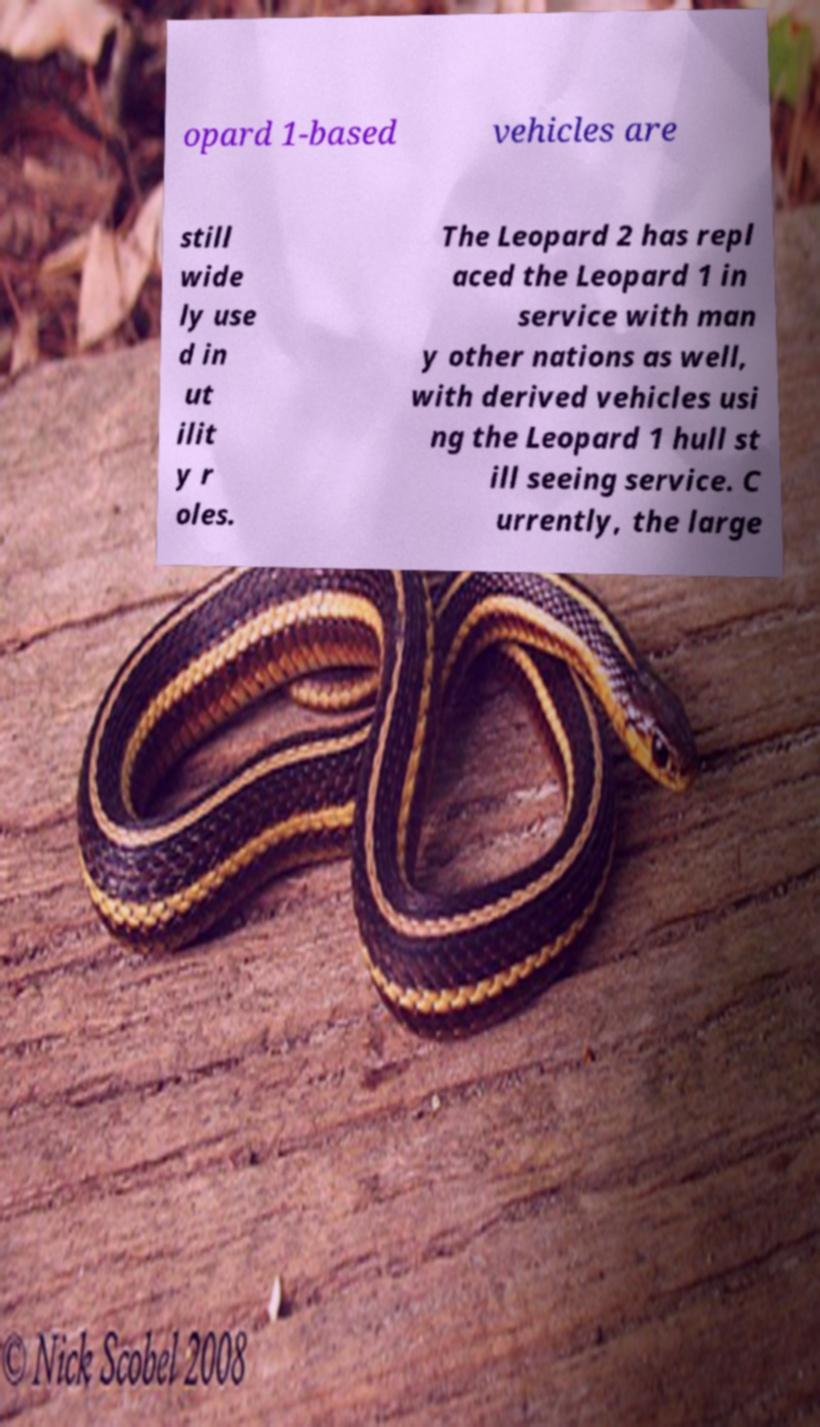What messages or text are displayed in this image? I need them in a readable, typed format. opard 1-based vehicles are still wide ly use d in ut ilit y r oles. The Leopard 2 has repl aced the Leopard 1 in service with man y other nations as well, with derived vehicles usi ng the Leopard 1 hull st ill seeing service. C urrently, the large 